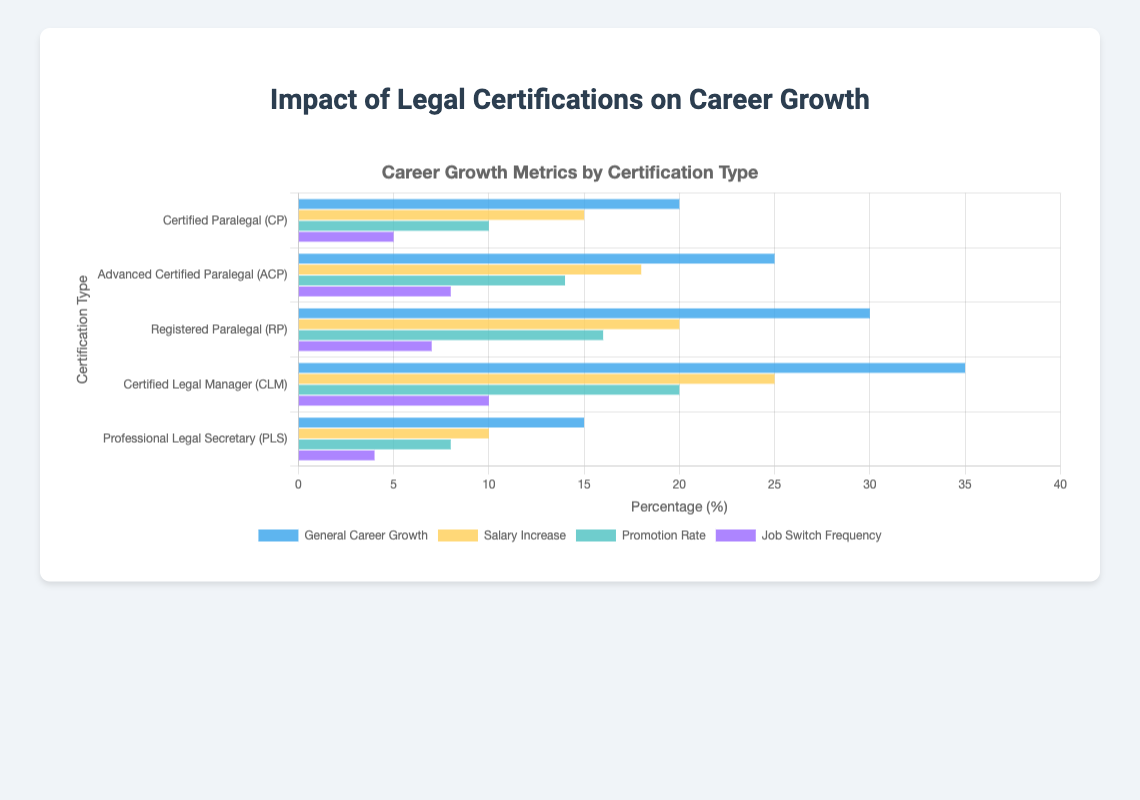What's the certification type that has the highest general career growth? To find the certification type with the highest general career growth, look at the "General Career Growth" bar for each certification. The largest bar is for the "Certified Legal Manager (CLM)" at 35%.
Answer: Certified Legal Manager (CLM) Which certification type shows the lowest salary increase percentage? To find this, compare the height of the "Salary Increase" bars across all certification types. The shortest bar is for "Professional Legal Secretary (PLS)" at 10%.
Answer: Professional Legal Secretary (PLS) What is the difference in promotion rate between the highest and lowest certification types? Find the highest promotion rate, which is "Certified Legal Manager (CLM)" at 20%, and the lowest, which is "Professional Legal Secretary (PLS)" at 8%. Then subtract the lowest from the highest: 20% - 8% = 12%.
Answer: 12% Which certification type has a higher job switch frequency: Registered Paralegal (RP) or Advanced Certified Paralegal (ACP)? Compare the "Job Switch Frequency" bars for both categories. Registered Paralegal (RP) is 7%, and Advanced Certified Paralegal (ACP) is 8%. Therefore, ACP is higher.
Answer: Advanced Certified Paralegal (ACP) What is the range of general career growth percentages among all certification types? To find the range, identify the highest and lowest general career growth percentages. The highest is 35% (Certified Legal Manager) and the lowest is 15% (Professional Legal Secretary). Subtract the lowest from the highest: 35% - 15% = 20%.
Answer: 20% How many certification types have a promotion rate of at least 10%? Look at the "Promotion Rate" bars and count those that are 10% or above. There are four certification types: CP, ACP, RP, and CLM.
Answer: 4 Which bar color represents the job switch frequency metric? Identify the color corresponding to "Job Switch Frequency" in the legend of the chart. It is represented by a purple bar.
Answer: Purple What's the total percentage of salary increase across all certification types? Add the salary increase percentages for all certification types: 15% (CP) + 18% (ACP) + 20% (RP) + 25% (CLM) + 10% (PLS) = 88%.
Answer: 88% For which certification type is the difference between general career growth and salary increase the smallest? Calculate the difference for each type: 
- CP: 20% - 15% = 5%
- ACP: 25% - 18% = 7%
- RP: 30% - 20% = 10%
- CLM: 35% - 25% = 10%
- PLS: 15% - 10% = 5%. The smallest difference is for Certified Paralegal (CP) and Professional Legal Secretary (PLS), both at 5%.
Answer: Certified Paralegal (CP), Professional Legal Secretary (PLS) 